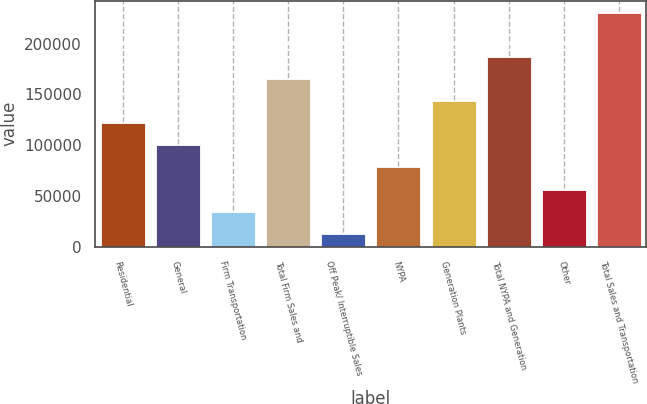Convert chart to OTSL. <chart><loc_0><loc_0><loc_500><loc_500><bar_chart><fcel>Residential<fcel>General<fcel>Firm Transportation<fcel>Total Firm Sales and<fcel>Off Peak/ Interruptible Sales<fcel>NYPA<fcel>Generation Plants<fcel>Total NYPA and Generation<fcel>Other<fcel>Total Sales and Transportation<nl><fcel>121534<fcel>99751.6<fcel>34404.4<fcel>165099<fcel>12622<fcel>77969.2<fcel>143316<fcel>186881<fcel>56186.8<fcel>230446<nl></chart> 